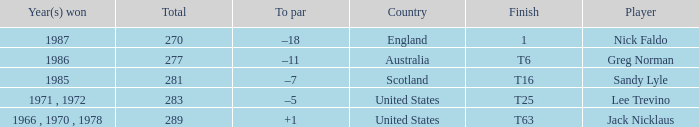What country has a total greater than 270, with sandy lyle as the player? Scotland. 